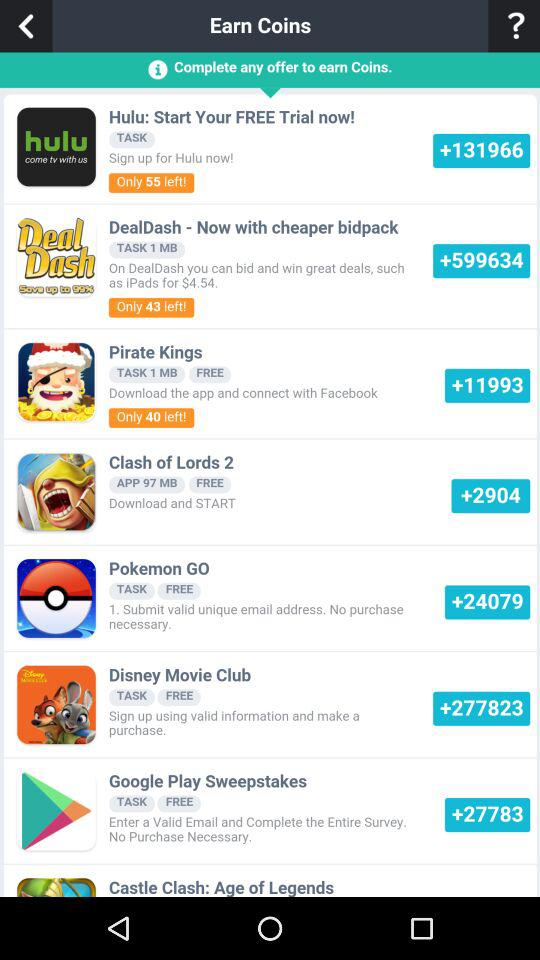How many coins can we earn by signing up using value information and making a purchase in "Disney Movie Club"? You can earn 277823 coins by signing up using value information and making a purchase. 